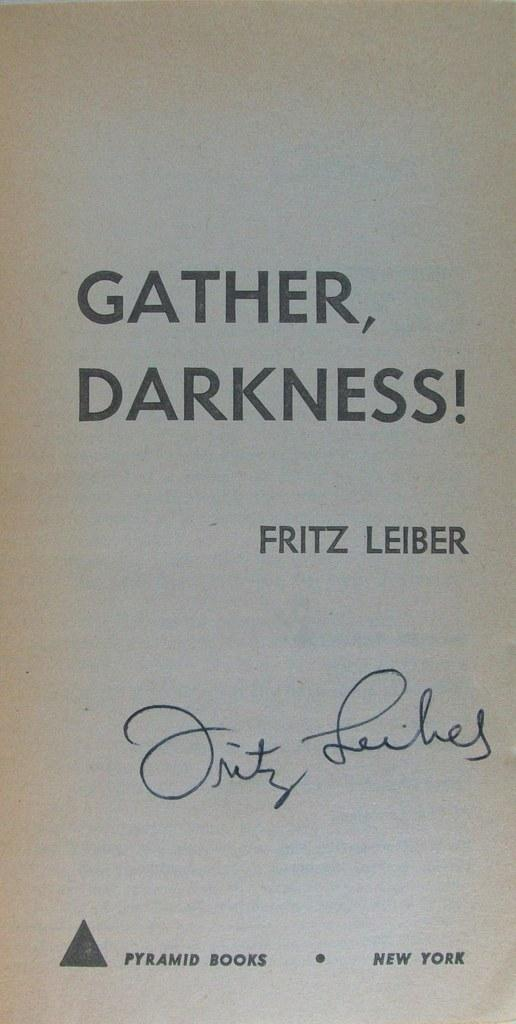Provide a one-sentence caption for the provided image. A book titled "Gather, Darkness!" by Fritz Leiber and signed by the author. 